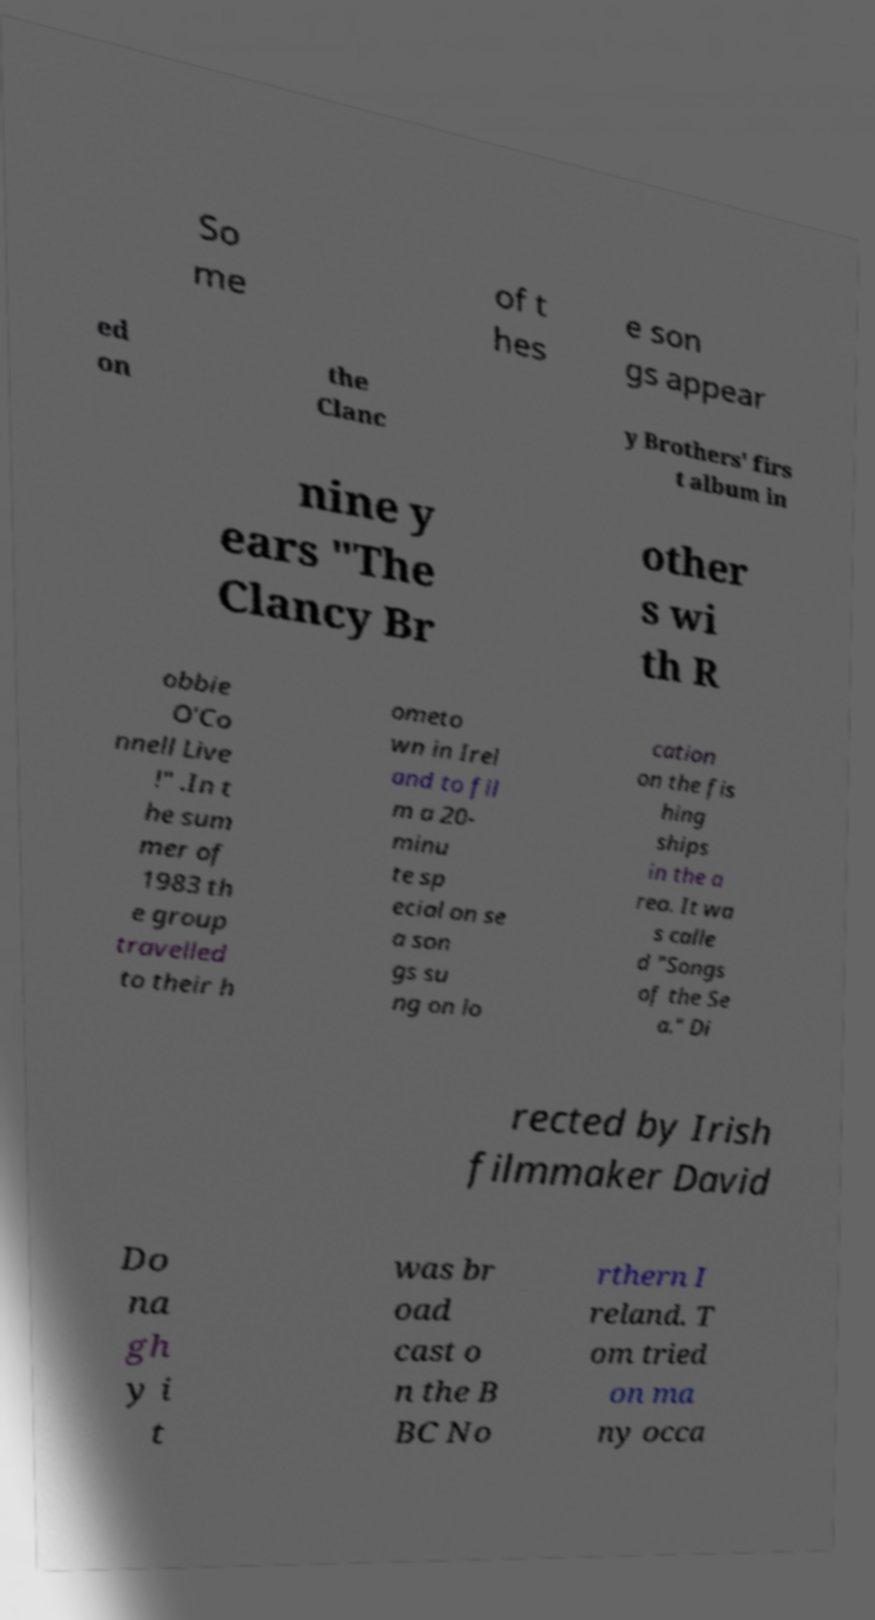Can you read and provide the text displayed in the image?This photo seems to have some interesting text. Can you extract and type it out for me? So me of t hes e son gs appear ed on the Clanc y Brothers' firs t album in nine y ears "The Clancy Br other s wi th R obbie O'Co nnell Live !" .In t he sum mer of 1983 th e group travelled to their h ometo wn in Irel and to fil m a 20- minu te sp ecial on se a son gs su ng on lo cation on the fis hing ships in the a rea. It wa s calle d "Songs of the Se a." Di rected by Irish filmmaker David Do na gh y i t was br oad cast o n the B BC No rthern I reland. T om tried on ma ny occa 